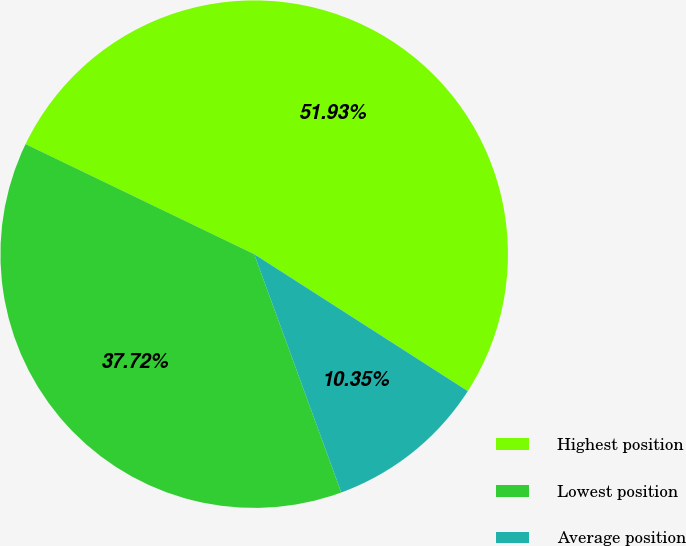Convert chart to OTSL. <chart><loc_0><loc_0><loc_500><loc_500><pie_chart><fcel>Highest position<fcel>Lowest position<fcel>Average position<nl><fcel>51.94%<fcel>37.72%<fcel>10.35%<nl></chart> 